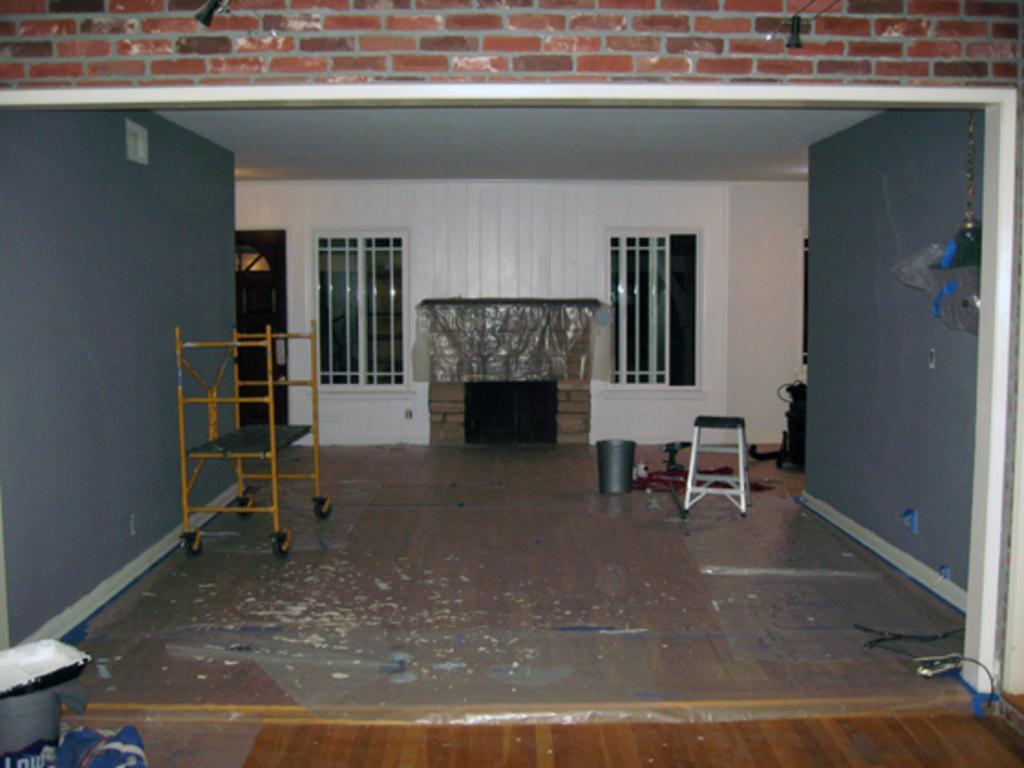Please provide a concise description of this image. In this image I can see the interior of the room in which I can see the floor, a metal stand, a stool, a bucket, a fireplace, few walls, few windows, the door, the ceiling and few other objects. 